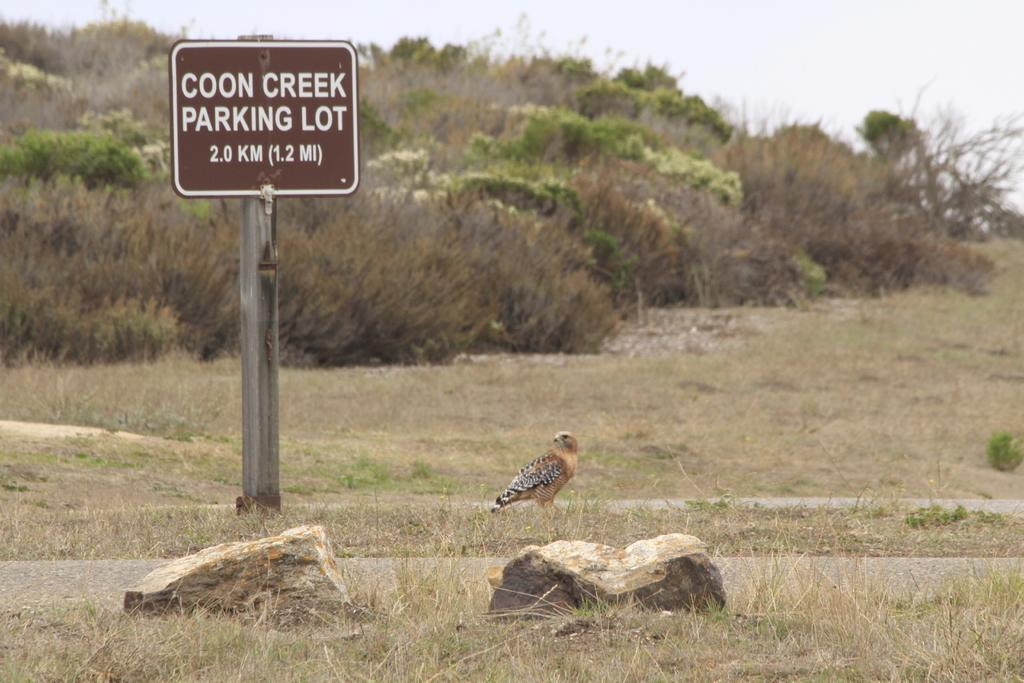What is the main subject of the image? There is a bird on a rock in the image. What type of terrain is visible in the image? There is grass on the ground in the image. What other natural elements can be seen in the image? There are trees visible in the image. What man-made object is present in the image? There is a sign board on a pole in the image. How would you describe the weather in the image? The sky is cloudy in the image. Is there a market in the image where the bird can buy seeds? There is no market present in the image, and it is not possible for the bird to buy seeds. Can you see a ray of light shining on the bird in the image? There is no ray of light visible in the image. 